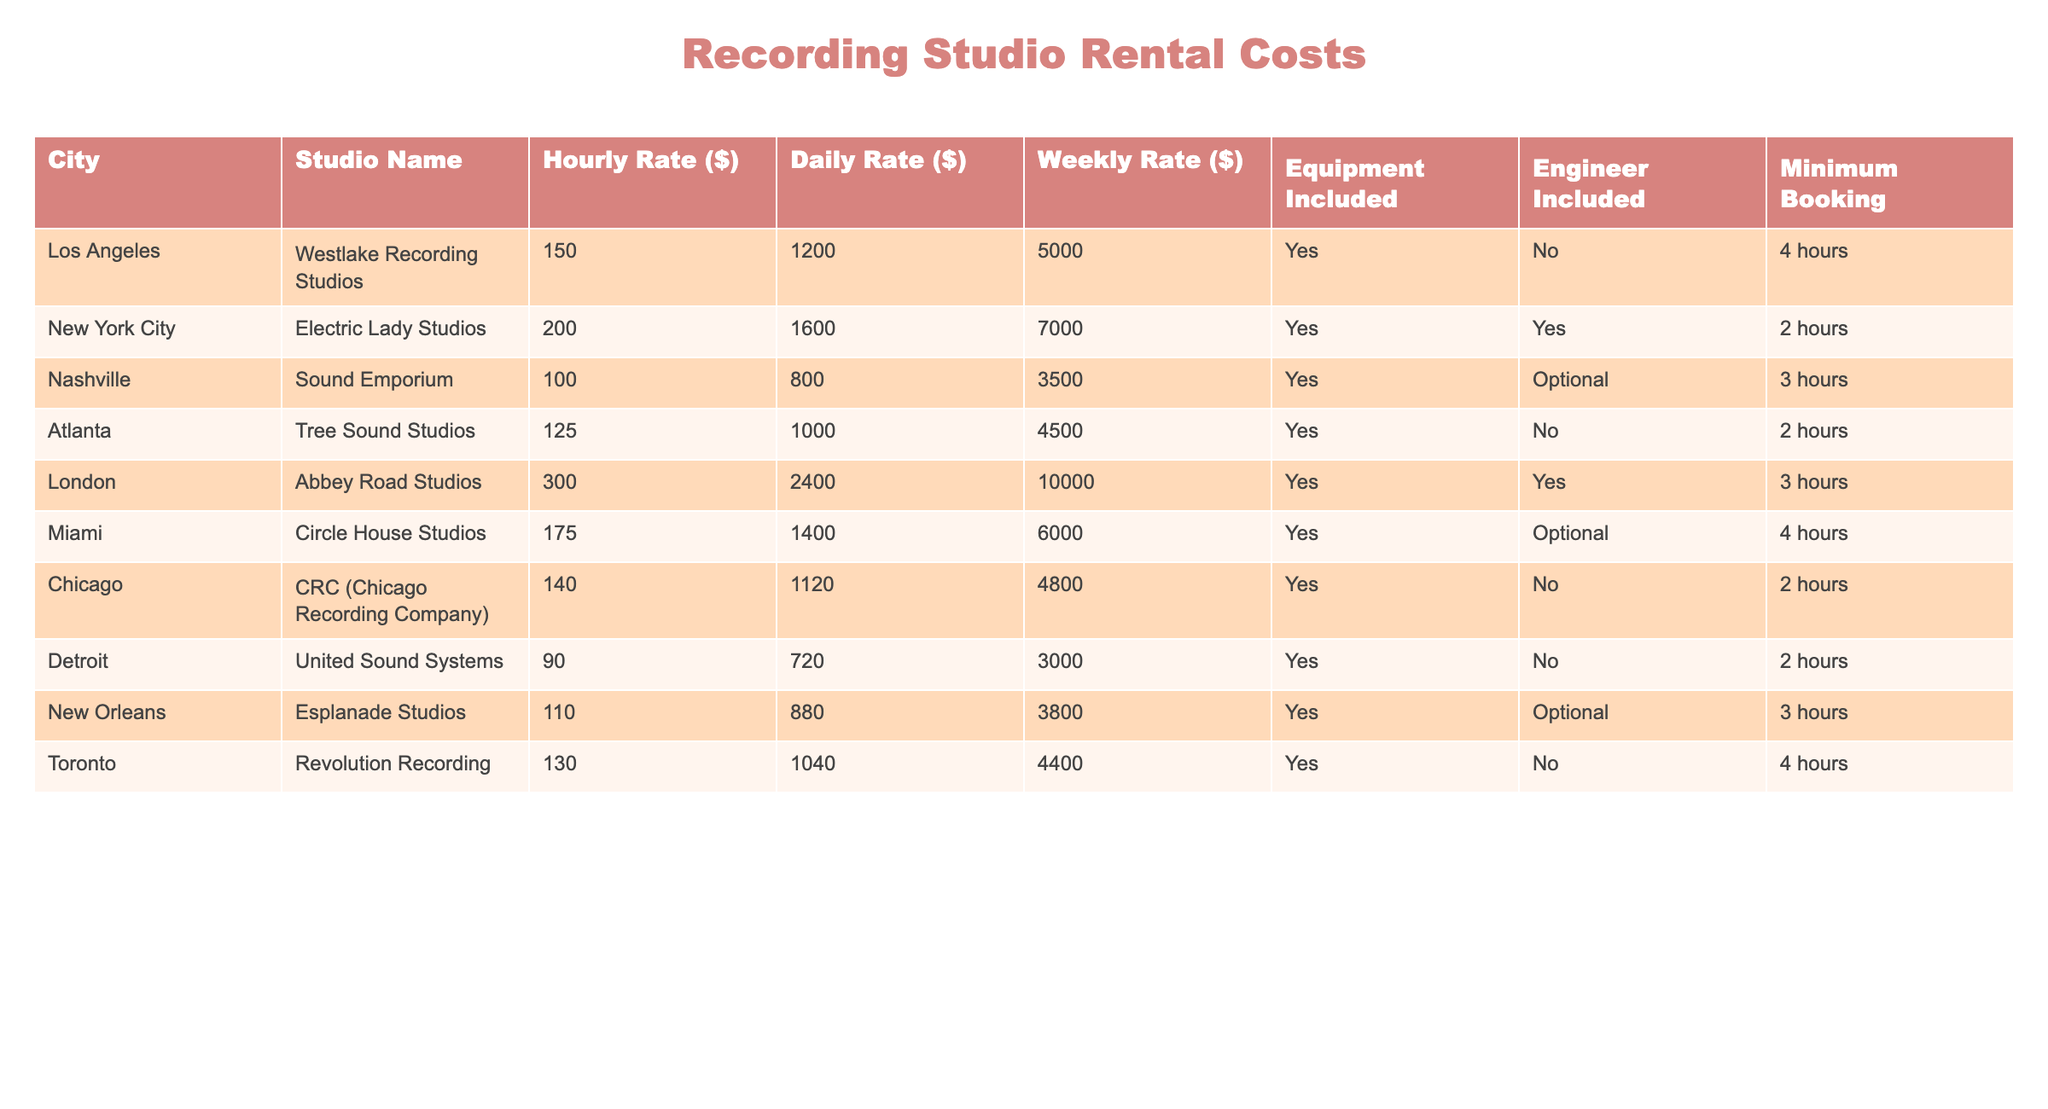What is the hourly rate for Electric Lady Studios in New York City? The table lists the hourly rate for Electric Lady Studios as $200. I can find this in the row corresponding to New York City, under the "Hourly Rate ($)" column.
Answer: 200 Which studio has the highest daily rate and what is that rate? Looking through the "Daily Rate ($)" column, I see that Abbey Road Studios in London has the highest rate of $2400. This is the maximum value in that column.
Answer: 2400 How much more is the weekly rate for Abbey Road Studios compared to Sound Emporium? The weekly rate for Abbey Road Studios is $10000 while Sound Emporium has a weekly rate of $3500. Subtracting these gives $10000 - $3500 = $6500. Therefore, Abbey Road Studios is $6500 more expensive per week than Sound Emporium.
Answer: 6500 Is engineer inclusion available at Circle House Studios? In the row for Circle House Studios, the "Engineer Included" column states "Optional." This means that engineer inclusion is not guaranteed but it is available if needed, making it not a simple yes or no situation.
Answer: Optional What is the average hourly rate of the studios in Nashville and Atlanta? The hourly rate for Sound Emporium in Nashville is $100, while Tree Sound Studios in Atlanta charges $125. To find the average, I add these two rates ($100 + $125 = $225) and divide by 2, getting an average hourly rate of $112.50.
Answer: 112.5 Which two cities have studios that require a minimum booking time of 2 hours? When checking the "Minimum Booking" column, I find that both Electric Lady Studios (New York City) and Tree Sound Studios (Atlanta) require a minimum booking time of 2 hours, which is clearly stated in their respective rows.
Answer: New York City and Atlanta What is the difference between the daily rates of CRC and United Sound Systems? CRC (Chicago Recording Company) has a daily rate of $1120, while United Sound Systems in Detroit has a daily rate of $720. By subtracting the two rates ($1120 - $720), I find that the difference is $400.
Answer: 400 Does Esplanade Studios include equipment in the rental? The table shows that Esplanade Studios includes equipment since the "Equipment Included" column states "Yes." Thus, it confirms that equipment is part of the rental package there.
Answer: Yes How many studios in the table have a minimum booking time of 3 hours? By checking the "Minimum Booking" column, I notice that Sound Emporium, Abbey Road Studios, and Esplanade Studios all require a minimum booking time of 3 hours, totaling three studios meeting this criterion.
Answer: 3 